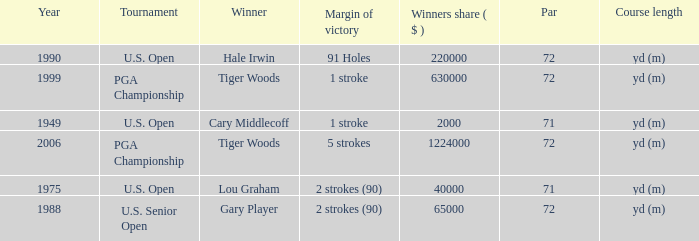When hale irwin is the winner what is the margin of victory? 91 Holes. 